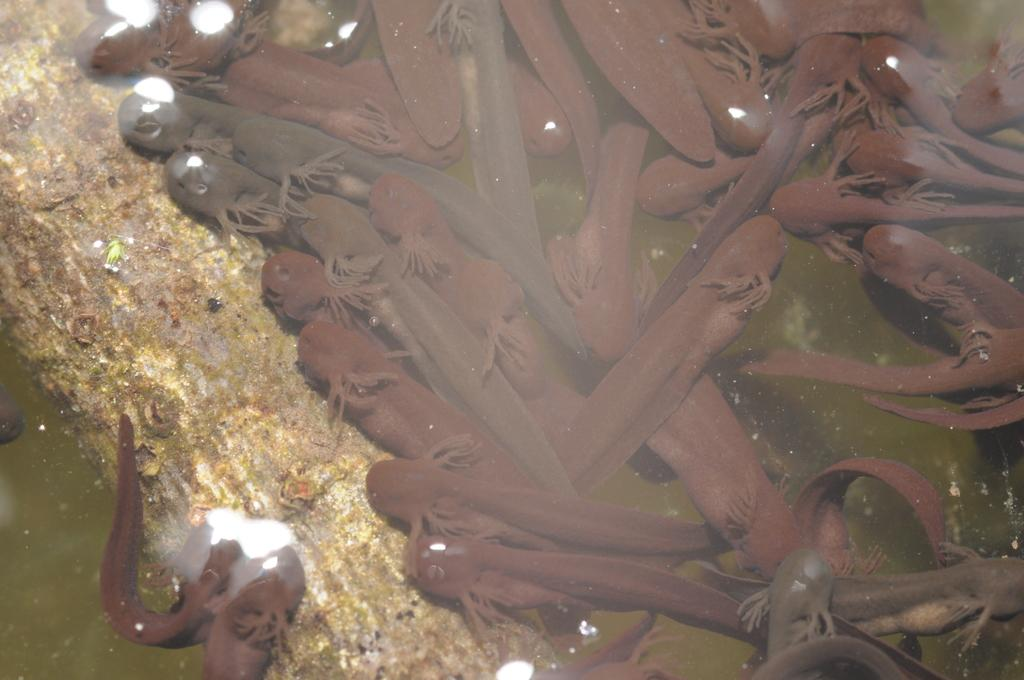What type of animals can be seen in the image? There are fishes in the image. What is the wooden object in the water? There is a wooden stem of a tree in the water. What is the primary element visible in the image? The water is visible in the image. How many strangers are sleeping on the cracker in the image? There are no strangers or crackers present in the image; it features fishes and a wooden stem of a tree in the water. 